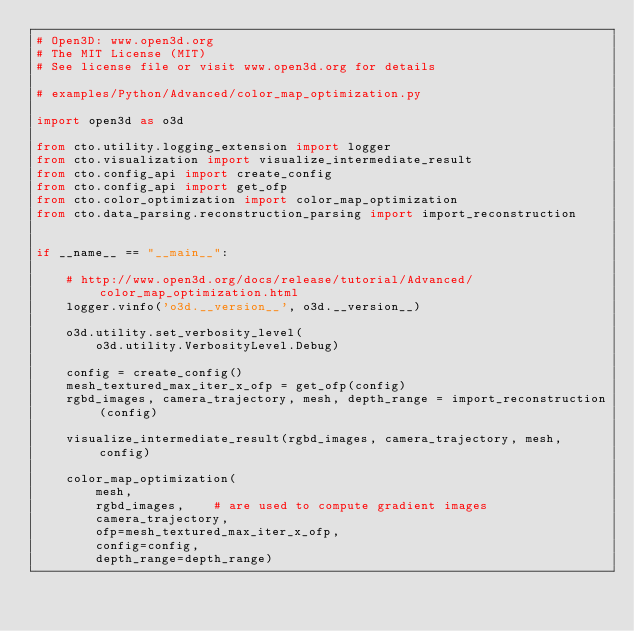<code> <loc_0><loc_0><loc_500><loc_500><_Python_># Open3D: www.open3d.org
# The MIT License (MIT)
# See license file or visit www.open3d.org for details

# examples/Python/Advanced/color_map_optimization.py

import open3d as o3d

from cto.utility.logging_extension import logger
from cto.visualization import visualize_intermediate_result
from cto.config_api import create_config
from cto.config_api import get_ofp
from cto.color_optimization import color_map_optimization
from cto.data_parsing.reconstruction_parsing import import_reconstruction


if __name__ == "__main__":

    # http://www.open3d.org/docs/release/tutorial/Advanced/color_map_optimization.html
    logger.vinfo('o3d.__version__', o3d.__version__)

    o3d.utility.set_verbosity_level(
        o3d.utility.VerbosityLevel.Debug)

    config = create_config()
    mesh_textured_max_iter_x_ofp = get_ofp(config)
    rgbd_images, camera_trajectory, mesh, depth_range = import_reconstruction(config)

    visualize_intermediate_result(rgbd_images, camera_trajectory, mesh, config)

    color_map_optimization(
        mesh,
        rgbd_images,    # are used to compute gradient images
        camera_trajectory,
        ofp=mesh_textured_max_iter_x_ofp,
        config=config,
        depth_range=depth_range)

</code> 